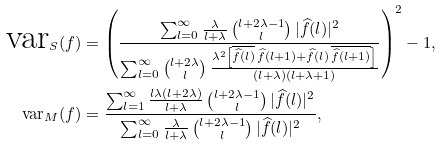Convert formula to latex. <formula><loc_0><loc_0><loc_500><loc_500>\text {var} _ { S } ( f ) & = \left ( \frac { \sum _ { l = 0 } ^ { \infty } \frac { \lambda } { l + \lambda } \, \binom { l + 2 \lambda - 1 } { l } \, | \widehat { f } ( l ) | ^ { 2 } } { \sum _ { l = 0 } ^ { \infty } \binom { l + 2 \lambda } { l } \, \frac { \lambda ^ { 2 } \left [ \overline { \widehat { f } ( l ) } \, \widehat { f } ( l + 1 ) + \widehat { f } ( l ) \, \overline { \widehat { f } ( l + 1 ) } \right ] } { ( l + \lambda ) ( l + \lambda + 1 ) } } \right ) ^ { 2 } - 1 , \\ \text {var} _ { M } ( f ) & = \frac { \sum _ { l = 1 } ^ { \infty } \frac { l \lambda ( l + 2 \lambda ) } { l + \lambda } \, \binom { l + 2 \lambda - 1 } { l } \, | \widehat { f } ( l ) | ^ { 2 } } { \sum _ { l = 0 } ^ { \infty } \frac { \lambda } { l + \lambda } \, \binom { l + 2 \lambda - 1 } { l } \, | \widehat { f } ( l ) | ^ { 2 } } ,</formula> 